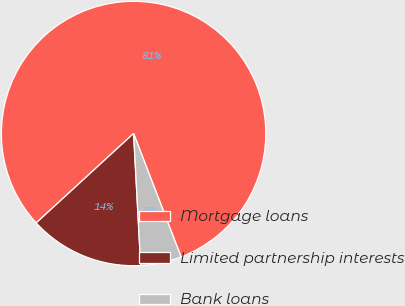Convert chart. <chart><loc_0><loc_0><loc_500><loc_500><pie_chart><fcel>Mortgage loans<fcel>Limited partnership interests<fcel>Bank loans<nl><fcel>80.97%<fcel>14.03%<fcel>5.0%<nl></chart> 